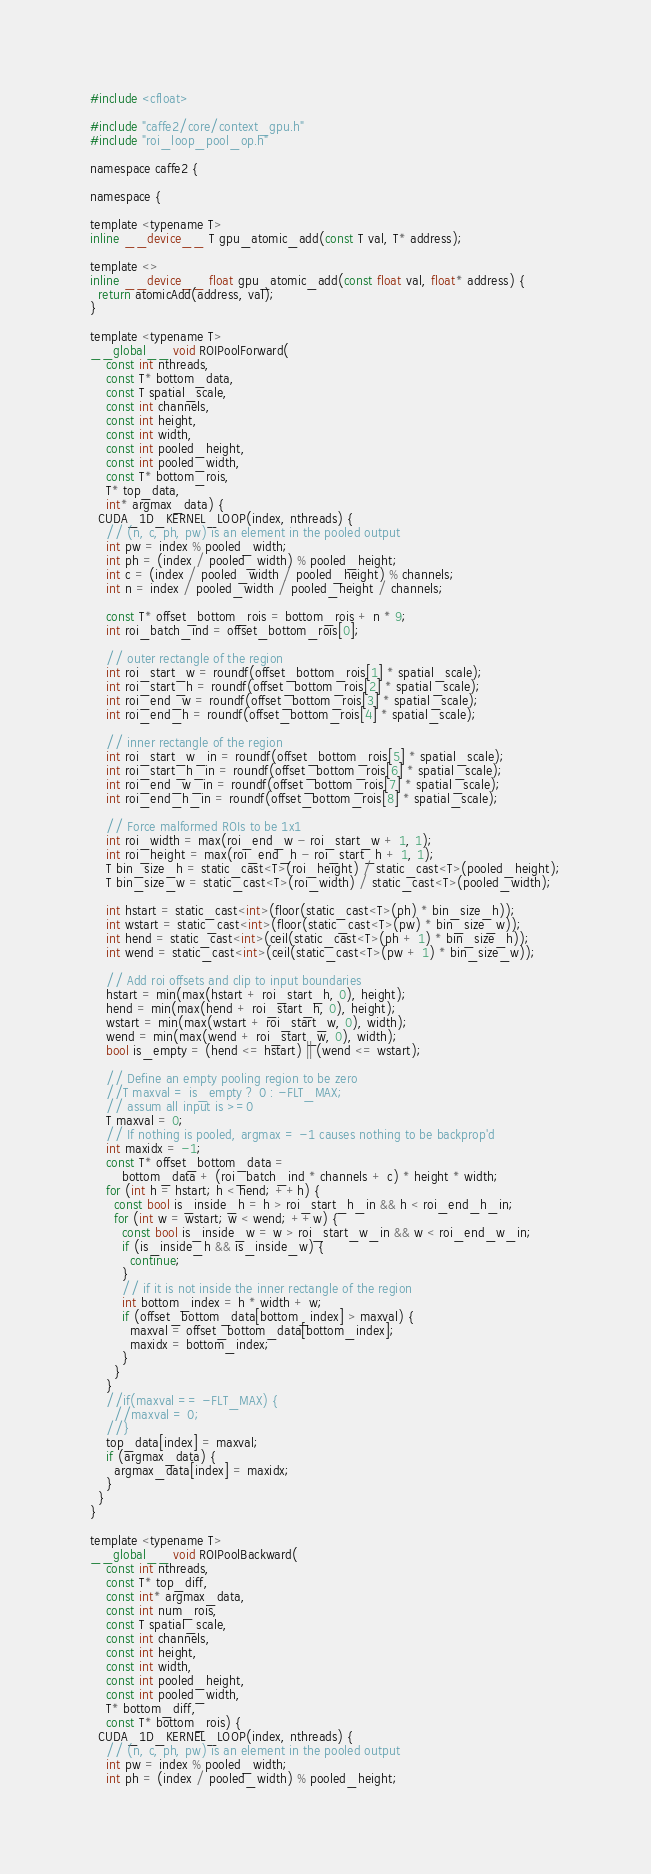<code> <loc_0><loc_0><loc_500><loc_500><_Cuda_>#include <cfloat>

#include "caffe2/core/context_gpu.h"
#include "roi_loop_pool_op.h"

namespace caffe2 {

namespace {

template <typename T>
inline __device__ T gpu_atomic_add(const T val, T* address);

template <>
inline __device__ float gpu_atomic_add(const float val, float* address) {
  return atomicAdd(address, val);
}

template <typename T>
__global__ void ROIPoolForward(
    const int nthreads,
    const T* bottom_data,
    const T spatial_scale,
    const int channels,
    const int height,
    const int width,
    const int pooled_height,
    const int pooled_width,
    const T* bottom_rois,
    T* top_data,
    int* argmax_data) {
  CUDA_1D_KERNEL_LOOP(index, nthreads) {
    // (n, c, ph, pw) is an element in the pooled output
    int pw = index % pooled_width;
    int ph = (index / pooled_width) % pooled_height;
    int c = (index / pooled_width / pooled_height) % channels;
    int n = index / pooled_width / pooled_height / channels;

    const T* offset_bottom_rois = bottom_rois + n * 9;
    int roi_batch_ind = offset_bottom_rois[0];

    // outer rectangle of the region
    int roi_start_w = roundf(offset_bottom_rois[1] * spatial_scale);
    int roi_start_h = roundf(offset_bottom_rois[2] * spatial_scale);
    int roi_end_w = roundf(offset_bottom_rois[3] * spatial_scale);
    int roi_end_h = roundf(offset_bottom_rois[4] * spatial_scale);

    // inner rectangle of the region
    int roi_start_w_in = roundf(offset_bottom_rois[5] * spatial_scale);
    int roi_start_h_in = roundf(offset_bottom_rois[6] * spatial_scale);
    int roi_end_w_in = roundf(offset_bottom_rois[7] * spatial_scale);
    int roi_end_h_in = roundf(offset_bottom_rois[8] * spatial_scale);

    // Force malformed ROIs to be 1x1
    int roi_width = max(roi_end_w - roi_start_w + 1, 1);
    int roi_height = max(roi_end_h - roi_start_h + 1, 1);
    T bin_size_h = static_cast<T>(roi_height) / static_cast<T>(pooled_height);
    T bin_size_w = static_cast<T>(roi_width) / static_cast<T>(pooled_width);

    int hstart = static_cast<int>(floor(static_cast<T>(ph) * bin_size_h));
    int wstart = static_cast<int>(floor(static_cast<T>(pw) * bin_size_w));
    int hend = static_cast<int>(ceil(static_cast<T>(ph + 1) * bin_size_h));
    int wend = static_cast<int>(ceil(static_cast<T>(pw + 1) * bin_size_w));

    // Add roi offsets and clip to input boundaries
    hstart = min(max(hstart + roi_start_h, 0), height);
    hend = min(max(hend + roi_start_h, 0), height);
    wstart = min(max(wstart + roi_start_w, 0), width);
    wend = min(max(wend + roi_start_w, 0), width);
    bool is_empty = (hend <= hstart) || (wend <= wstart);

    // Define an empty pooling region to be zero
    //T maxval = is_empty ? 0 : -FLT_MAX;
    // assum all input is >=0
    T maxval = 0;
    // If nothing is pooled, argmax = -1 causes nothing to be backprop'd
    int maxidx = -1;
    const T* offset_bottom_data =
        bottom_data + (roi_batch_ind * channels + c) * height * width;
    for (int h = hstart; h < hend; ++h) {
      const bool is_inside_h = h > roi_start_h_in && h < roi_end_h_in;
      for (int w = wstart; w < wend; ++w) {
        const bool is_inside_w = w > roi_start_w_in && w < roi_end_w_in;
        if (is_inside_h && is_inside_w) {
          continue;
        }
        // if it is not inside the inner rectangle of the region
        int bottom_index = h * width + w;
        if (offset_bottom_data[bottom_index] > maxval) {
          maxval = offset_bottom_data[bottom_index];
          maxidx = bottom_index;
        }
      }
    }
    //if(maxval == -FLT_MAX) {
      //maxval = 0;
    //}
    top_data[index] = maxval;
    if (argmax_data) {
      argmax_data[index] = maxidx;
    }
  }
}

template <typename T>
__global__ void ROIPoolBackward(
    const int nthreads,
    const T* top_diff,
    const int* argmax_data,
    const int num_rois,
    const T spatial_scale,
    const int channels,
    const int height,
    const int width,
    const int pooled_height,
    const int pooled_width,
    T* bottom_diff,
    const T* bottom_rois) {
  CUDA_1D_KERNEL_LOOP(index, nthreads) {
    // (n, c, ph, pw) is an element in the pooled output
    int pw = index % pooled_width;
    int ph = (index / pooled_width) % pooled_height;</code> 